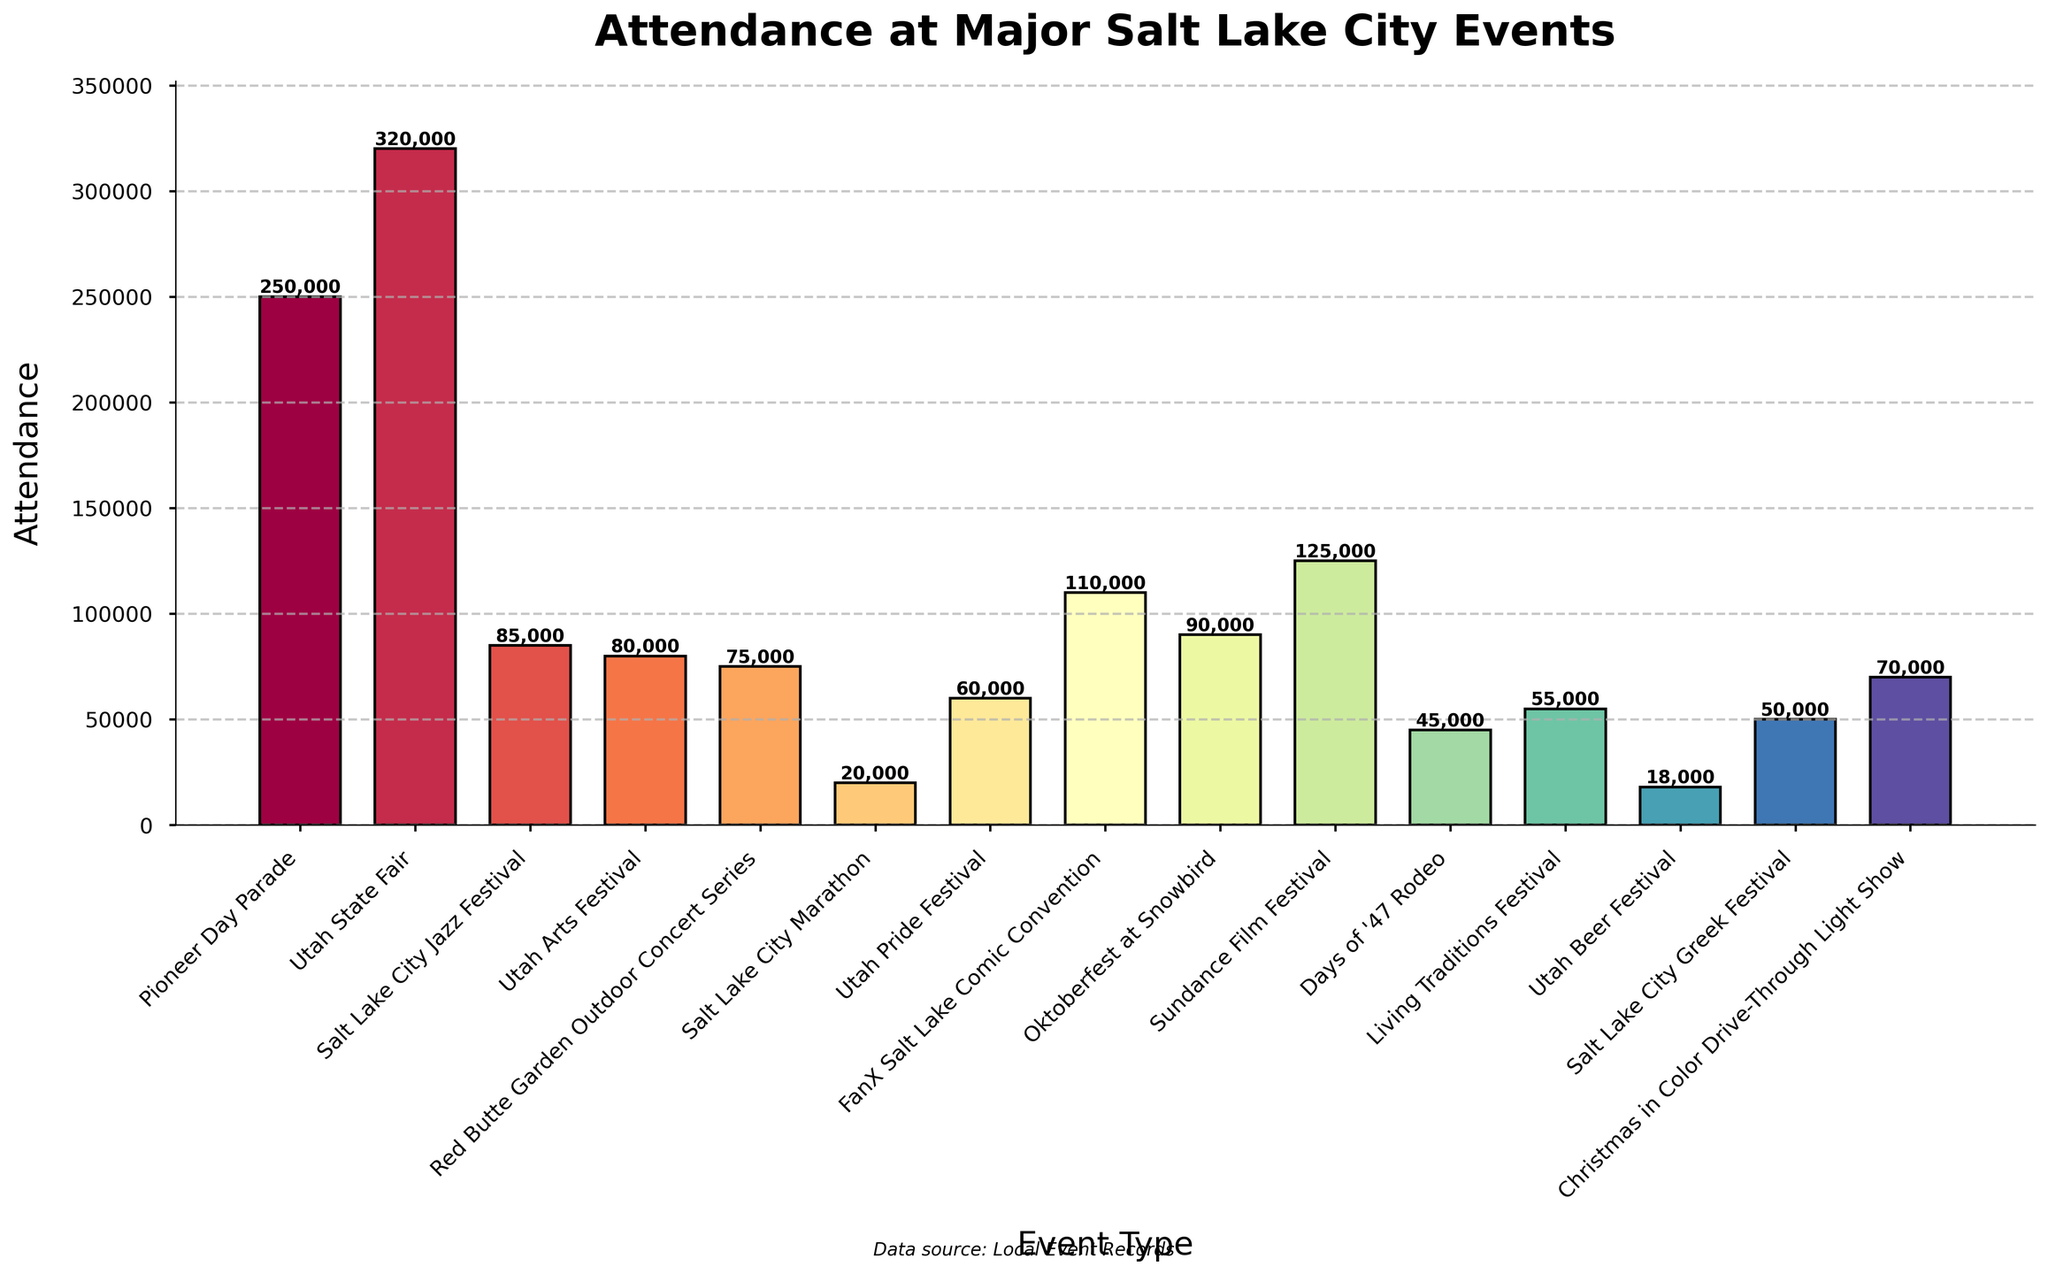Which event had the highest attendance? To find the event with the highest attendance, look for the tallest bar in the chart and read the associated event name.
Answer: Utah State Fair What's the difference between the attendance at FanX Salt Lake Comic Convention and Days of '47 Rodeo? Identify the heights of the bars for both events from the chart. The attendance for FanX Salt Lake Comic Convention is 110,000 and for Days of '47 Rodeo is 45,000. The difference is 110,000 - 45,000.
Answer: 65,000 How many events had an attendance of over 100,000? Count the number of bars in the chart that reach an attendance of 100,000 or more. These are Utah State Fair, Pioneer Day Parade, FanX Salt Lake Comic Convention, and Sundance Film Festival.
Answer: 4 Which event had the lowest attendance, and what was it? Locate the shortest bar in the chart and read the associated event name and its height.
Answer: Utah Beer Festival, 18,000 What is the average attendance of the Pioneer Day Parade, Salt Lake City Jazz Festival, and Utah Arts Festival? Find the attendance numbers for the three events from the chart: Pioneer Day Parade (250,000), Salt Lake City Jazz Festival (85,000), and Utah Arts Festival (80,000). Calculate (250,000 + 85,000 + 80,000) / 3.
Answer: 138,333 How does the attendance at the Christmas in Color Drive-Through Light Show compare to the Red Butte Garden Outdoor Concert Series? Look at the height of the bars for both events. The bar heights show that the Christmas in Color Drive-Through Light Show had an attendance of 70,000 and the Red Butte Garden Outdoor Concert Series had 75,000. The former is slightly lower.
Answer: It’s 5,000 less What is the combined attendance of the Utah State Fair and the Sundance Film Festival? Find the attendance for each event from the chart and add them together: Utah State Fair (320,000) + Sundance Film Festival (125,000).
Answer: 445,000 Is the attendance at the Oktoberfest at Snowbird more or less than the Utah Pride Festival? Compare the bar heights for both events. The Oktoberfest at Snowbird has 90,000 attendees, while the Utah Pride Festival has 60,000 attendees.
Answer: More by 30,000 What color represents the bar with the highest attendance? Identify the tallest bar on the chart (Utah State Fair) and note its color.
Answer: Likely a distinct bright color within the palette used (specific color depends on rendering) What is the total attendance for the events with less than 50,000 attendees? Identify the events with less than 50,000 from the chart (Salt Lake City Marathon: 20,000; Utah Beer Festival: 18,000; Days of '47 Rodeo: 45,000; Salt Lake City Greek Festival: 50,000 is excluded; Living Traditions Festival: 55,000 is excluded). Calculate 20,000 + 18,000 + 45,000.
Answer: 83,000 